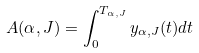<formula> <loc_0><loc_0><loc_500><loc_500>A ( \alpha , J ) = \int _ { 0 } ^ { T _ { \alpha , J } } { y _ { \alpha , J } ( t ) d t }</formula> 